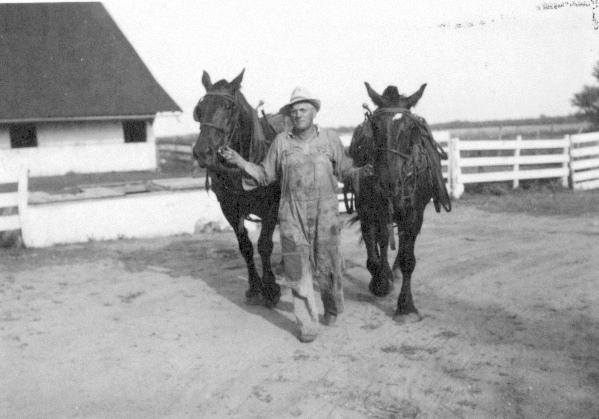What color is the horse?
Quick response, please. Brown. How cold is it?
Keep it brief. Not cold. Is this location crowded?
Answer briefly. No. How many rooftops are there?
Give a very brief answer. 1. What is this man's occupation?
Short answer required. Farmer. Is a lady walking the horse?
Concise answer only. No. Is this a modern photo?
Give a very brief answer. No. How many legs are easily visible for the animal on the man's left?
Be succinct. 2. Is this a vacation activity?
Quick response, please. No. How many people are there?
Keep it brief. 1. Are they going for a ride?
Keep it brief. No. What is the man doing with his hands?
Short answer required. Leading horses. How many officers are riding horses?
Short answer required. 0. What does the horse have on its head?
Concise answer only. Harness. What country is this in?
Keep it brief. America. What color is the horse to the right?
Answer briefly. Black. What are they standing next to?
Short answer required. Man. What does it appear the man is doing?
Concise answer only. Walking horses. Are the animals in the wild?
Quick response, please. No. How many cows are here?
Give a very brief answer. 0. What kind of transportation is this?
Give a very brief answer. Horse. Why are the people wearing warm clothing?
Quick response, please. Cold. Is this a riding academy?
Short answer required. No. What is the man wearing?
Quick response, please. Overalls. What color is the gate?
Give a very brief answer. White. Is the man's hat too small for him?
Keep it brief. No. Is he wearing a suit?
Concise answer only. No. Do these animals produce dairy products?
Concise answer only. No. What kind of fence is in the photo?
Write a very short answer. Wood. Which direction is the shadow?
Answer briefly. Left. What is the color of the rope?
Short answer required. Black. What color is the nose of the horse?
Give a very brief answer. Brown. Is there a person in the distance?
Quick response, please. No. Is there a special event going on?
Concise answer only. No. What type of tradesman would need to work on this animal's hoof?
Quick response, please. Farrier. 